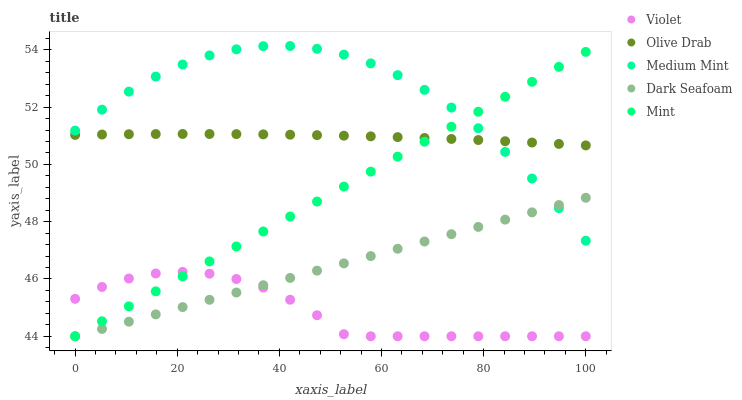Does Violet have the minimum area under the curve?
Answer yes or no. Yes. Does Medium Mint have the maximum area under the curve?
Answer yes or no. Yes. Does Dark Seafoam have the minimum area under the curve?
Answer yes or no. No. Does Dark Seafoam have the maximum area under the curve?
Answer yes or no. No. Is Dark Seafoam the smoothest?
Answer yes or no. Yes. Is Medium Mint the roughest?
Answer yes or no. Yes. Is Mint the smoothest?
Answer yes or no. No. Is Mint the roughest?
Answer yes or no. No. Does Dark Seafoam have the lowest value?
Answer yes or no. Yes. Does Olive Drab have the lowest value?
Answer yes or no. No. Does Medium Mint have the highest value?
Answer yes or no. Yes. Does Dark Seafoam have the highest value?
Answer yes or no. No. Is Violet less than Olive Drab?
Answer yes or no. Yes. Is Olive Drab greater than Dark Seafoam?
Answer yes or no. Yes. Does Mint intersect Olive Drab?
Answer yes or no. Yes. Is Mint less than Olive Drab?
Answer yes or no. No. Is Mint greater than Olive Drab?
Answer yes or no. No. Does Violet intersect Olive Drab?
Answer yes or no. No. 